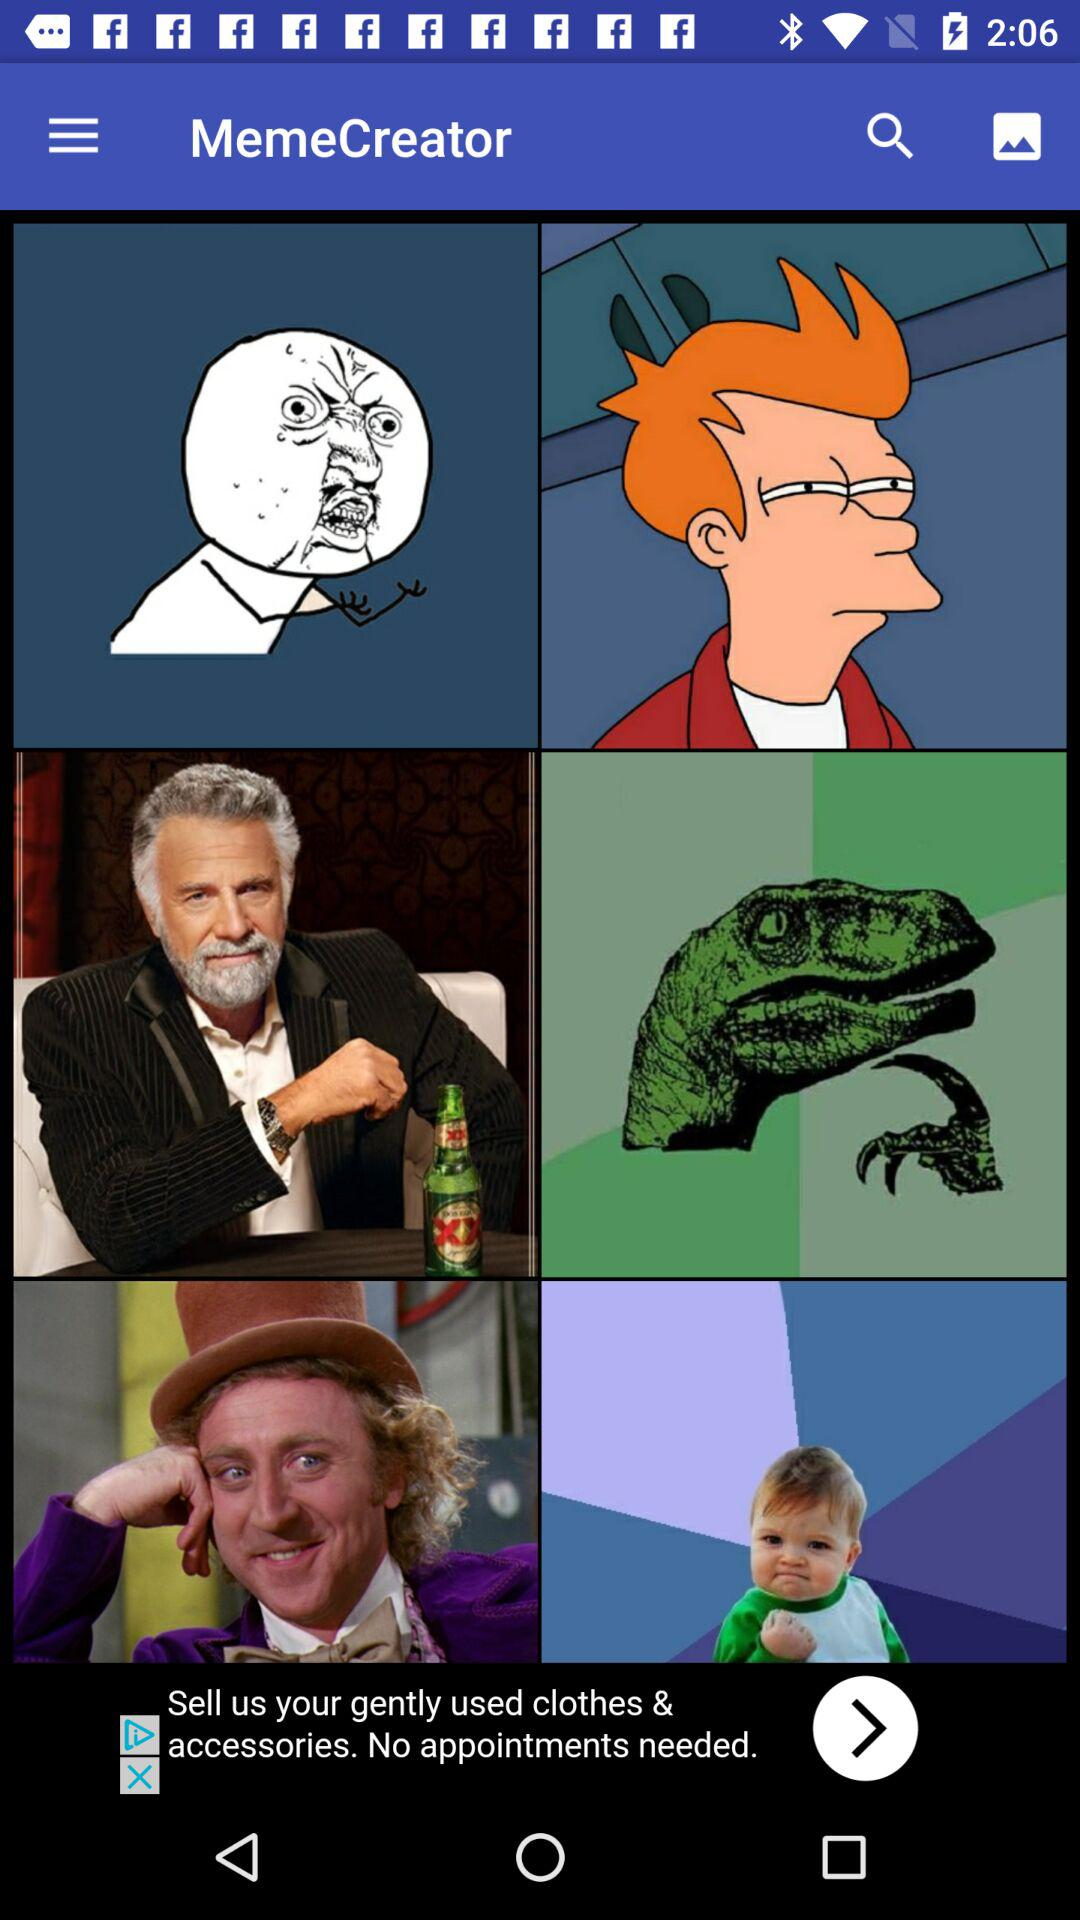What is the app name? The app name is "MemeCreator". 